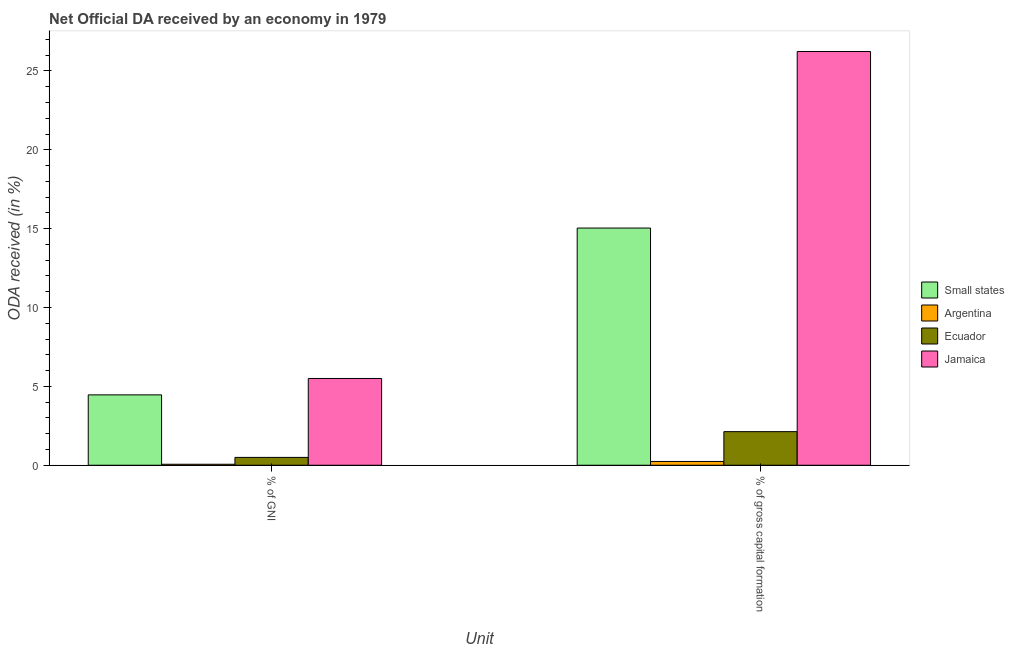How many groups of bars are there?
Provide a succinct answer. 2. Are the number of bars per tick equal to the number of legend labels?
Provide a succinct answer. Yes. What is the label of the 2nd group of bars from the left?
Your response must be concise. % of gross capital formation. What is the oda received as percentage of gross capital formation in Jamaica?
Offer a terse response. 26.23. Across all countries, what is the maximum oda received as percentage of gni?
Offer a terse response. 5.5. Across all countries, what is the minimum oda received as percentage of gni?
Offer a terse response. 0.06. In which country was the oda received as percentage of gni maximum?
Provide a short and direct response. Jamaica. What is the total oda received as percentage of gross capital formation in the graph?
Ensure brevity in your answer.  43.65. What is the difference between the oda received as percentage of gni in Ecuador and that in Argentina?
Offer a terse response. 0.43. What is the difference between the oda received as percentage of gross capital formation in Ecuador and the oda received as percentage of gni in Argentina?
Your response must be concise. 2.07. What is the average oda received as percentage of gross capital formation per country?
Your answer should be compact. 10.91. What is the difference between the oda received as percentage of gni and oda received as percentage of gross capital formation in Argentina?
Offer a very short reply. -0.18. What is the ratio of the oda received as percentage of gross capital formation in Argentina to that in Small states?
Give a very brief answer. 0.02. In how many countries, is the oda received as percentage of gni greater than the average oda received as percentage of gni taken over all countries?
Make the answer very short. 2. What does the 2nd bar from the left in % of GNI represents?
Offer a very short reply. Argentina. What does the 1st bar from the right in % of gross capital formation represents?
Your response must be concise. Jamaica. How many countries are there in the graph?
Offer a terse response. 4. What is the difference between two consecutive major ticks on the Y-axis?
Offer a terse response. 5. Are the values on the major ticks of Y-axis written in scientific E-notation?
Make the answer very short. No. Does the graph contain any zero values?
Offer a terse response. No. Where does the legend appear in the graph?
Keep it short and to the point. Center right. How many legend labels are there?
Provide a short and direct response. 4. How are the legend labels stacked?
Provide a succinct answer. Vertical. What is the title of the graph?
Your response must be concise. Net Official DA received by an economy in 1979. Does "Middle income" appear as one of the legend labels in the graph?
Provide a short and direct response. No. What is the label or title of the X-axis?
Ensure brevity in your answer.  Unit. What is the label or title of the Y-axis?
Your response must be concise. ODA received (in %). What is the ODA received (in %) of Small states in % of GNI?
Keep it short and to the point. 4.46. What is the ODA received (in %) in Argentina in % of GNI?
Ensure brevity in your answer.  0.06. What is the ODA received (in %) of Ecuador in % of GNI?
Give a very brief answer. 0.5. What is the ODA received (in %) in Jamaica in % of GNI?
Your answer should be compact. 5.5. What is the ODA received (in %) of Small states in % of gross capital formation?
Your response must be concise. 15.04. What is the ODA received (in %) in Argentina in % of gross capital formation?
Keep it short and to the point. 0.24. What is the ODA received (in %) of Ecuador in % of gross capital formation?
Your answer should be compact. 2.13. What is the ODA received (in %) of Jamaica in % of gross capital formation?
Make the answer very short. 26.23. Across all Unit, what is the maximum ODA received (in %) in Small states?
Your response must be concise. 15.04. Across all Unit, what is the maximum ODA received (in %) of Argentina?
Ensure brevity in your answer.  0.24. Across all Unit, what is the maximum ODA received (in %) of Ecuador?
Offer a terse response. 2.13. Across all Unit, what is the maximum ODA received (in %) in Jamaica?
Your answer should be compact. 26.23. Across all Unit, what is the minimum ODA received (in %) of Small states?
Provide a succinct answer. 4.46. Across all Unit, what is the minimum ODA received (in %) in Argentina?
Your answer should be compact. 0.06. Across all Unit, what is the minimum ODA received (in %) in Ecuador?
Make the answer very short. 0.5. Across all Unit, what is the minimum ODA received (in %) in Jamaica?
Provide a succinct answer. 5.5. What is the total ODA received (in %) of Small states in the graph?
Your answer should be compact. 19.5. What is the total ODA received (in %) of Argentina in the graph?
Your response must be concise. 0.3. What is the total ODA received (in %) in Ecuador in the graph?
Make the answer very short. 2.63. What is the total ODA received (in %) in Jamaica in the graph?
Keep it short and to the point. 31.74. What is the difference between the ODA received (in %) of Small states in % of GNI and that in % of gross capital formation?
Offer a terse response. -10.58. What is the difference between the ODA received (in %) of Argentina in % of GNI and that in % of gross capital formation?
Make the answer very short. -0.18. What is the difference between the ODA received (in %) of Ecuador in % of GNI and that in % of gross capital formation?
Keep it short and to the point. -1.63. What is the difference between the ODA received (in %) of Jamaica in % of GNI and that in % of gross capital formation?
Your answer should be compact. -20.73. What is the difference between the ODA received (in %) in Small states in % of GNI and the ODA received (in %) in Argentina in % of gross capital formation?
Make the answer very short. 4.22. What is the difference between the ODA received (in %) in Small states in % of GNI and the ODA received (in %) in Ecuador in % of gross capital formation?
Your answer should be compact. 2.33. What is the difference between the ODA received (in %) in Small states in % of GNI and the ODA received (in %) in Jamaica in % of gross capital formation?
Ensure brevity in your answer.  -21.77. What is the difference between the ODA received (in %) of Argentina in % of GNI and the ODA received (in %) of Ecuador in % of gross capital formation?
Keep it short and to the point. -2.07. What is the difference between the ODA received (in %) in Argentina in % of GNI and the ODA received (in %) in Jamaica in % of gross capital formation?
Offer a terse response. -26.17. What is the difference between the ODA received (in %) of Ecuador in % of GNI and the ODA received (in %) of Jamaica in % of gross capital formation?
Give a very brief answer. -25.74. What is the average ODA received (in %) of Small states per Unit?
Offer a terse response. 9.75. What is the average ODA received (in %) of Argentina per Unit?
Make the answer very short. 0.15. What is the average ODA received (in %) in Ecuador per Unit?
Offer a terse response. 1.31. What is the average ODA received (in %) of Jamaica per Unit?
Offer a very short reply. 15.87. What is the difference between the ODA received (in %) in Small states and ODA received (in %) in Argentina in % of GNI?
Your answer should be compact. 4.4. What is the difference between the ODA received (in %) of Small states and ODA received (in %) of Ecuador in % of GNI?
Give a very brief answer. 3.96. What is the difference between the ODA received (in %) in Small states and ODA received (in %) in Jamaica in % of GNI?
Ensure brevity in your answer.  -1.04. What is the difference between the ODA received (in %) in Argentina and ODA received (in %) in Ecuador in % of GNI?
Your answer should be compact. -0.43. What is the difference between the ODA received (in %) in Argentina and ODA received (in %) in Jamaica in % of GNI?
Make the answer very short. -5.44. What is the difference between the ODA received (in %) in Ecuador and ODA received (in %) in Jamaica in % of GNI?
Make the answer very short. -5. What is the difference between the ODA received (in %) of Small states and ODA received (in %) of Argentina in % of gross capital formation?
Offer a very short reply. 14.8. What is the difference between the ODA received (in %) of Small states and ODA received (in %) of Ecuador in % of gross capital formation?
Ensure brevity in your answer.  12.91. What is the difference between the ODA received (in %) of Small states and ODA received (in %) of Jamaica in % of gross capital formation?
Keep it short and to the point. -11.19. What is the difference between the ODA received (in %) of Argentina and ODA received (in %) of Ecuador in % of gross capital formation?
Offer a very short reply. -1.89. What is the difference between the ODA received (in %) in Argentina and ODA received (in %) in Jamaica in % of gross capital formation?
Ensure brevity in your answer.  -25.99. What is the difference between the ODA received (in %) in Ecuador and ODA received (in %) in Jamaica in % of gross capital formation?
Offer a terse response. -24.1. What is the ratio of the ODA received (in %) of Small states in % of GNI to that in % of gross capital formation?
Offer a very short reply. 0.3. What is the ratio of the ODA received (in %) of Argentina in % of GNI to that in % of gross capital formation?
Provide a short and direct response. 0.26. What is the ratio of the ODA received (in %) in Ecuador in % of GNI to that in % of gross capital formation?
Make the answer very short. 0.23. What is the ratio of the ODA received (in %) of Jamaica in % of GNI to that in % of gross capital formation?
Offer a terse response. 0.21. What is the difference between the highest and the second highest ODA received (in %) of Small states?
Make the answer very short. 10.58. What is the difference between the highest and the second highest ODA received (in %) of Argentina?
Provide a short and direct response. 0.18. What is the difference between the highest and the second highest ODA received (in %) in Ecuador?
Keep it short and to the point. 1.63. What is the difference between the highest and the second highest ODA received (in %) of Jamaica?
Make the answer very short. 20.73. What is the difference between the highest and the lowest ODA received (in %) of Small states?
Provide a succinct answer. 10.58. What is the difference between the highest and the lowest ODA received (in %) of Argentina?
Make the answer very short. 0.18. What is the difference between the highest and the lowest ODA received (in %) of Ecuador?
Give a very brief answer. 1.63. What is the difference between the highest and the lowest ODA received (in %) in Jamaica?
Give a very brief answer. 20.73. 